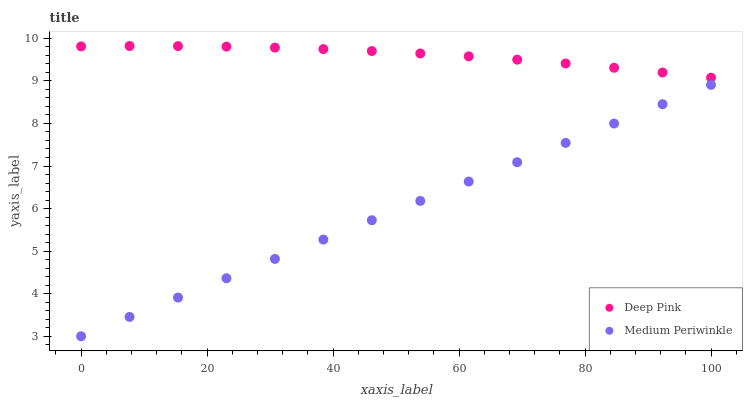Does Medium Periwinkle have the minimum area under the curve?
Answer yes or no. Yes. Does Deep Pink have the maximum area under the curve?
Answer yes or no. Yes. Does Medium Periwinkle have the maximum area under the curve?
Answer yes or no. No. Is Medium Periwinkle the smoothest?
Answer yes or no. Yes. Is Deep Pink the roughest?
Answer yes or no. Yes. Is Medium Periwinkle the roughest?
Answer yes or no. No. Does Medium Periwinkle have the lowest value?
Answer yes or no. Yes. Does Deep Pink have the highest value?
Answer yes or no. Yes. Does Medium Periwinkle have the highest value?
Answer yes or no. No. Is Medium Periwinkle less than Deep Pink?
Answer yes or no. Yes. Is Deep Pink greater than Medium Periwinkle?
Answer yes or no. Yes. Does Medium Periwinkle intersect Deep Pink?
Answer yes or no. No. 